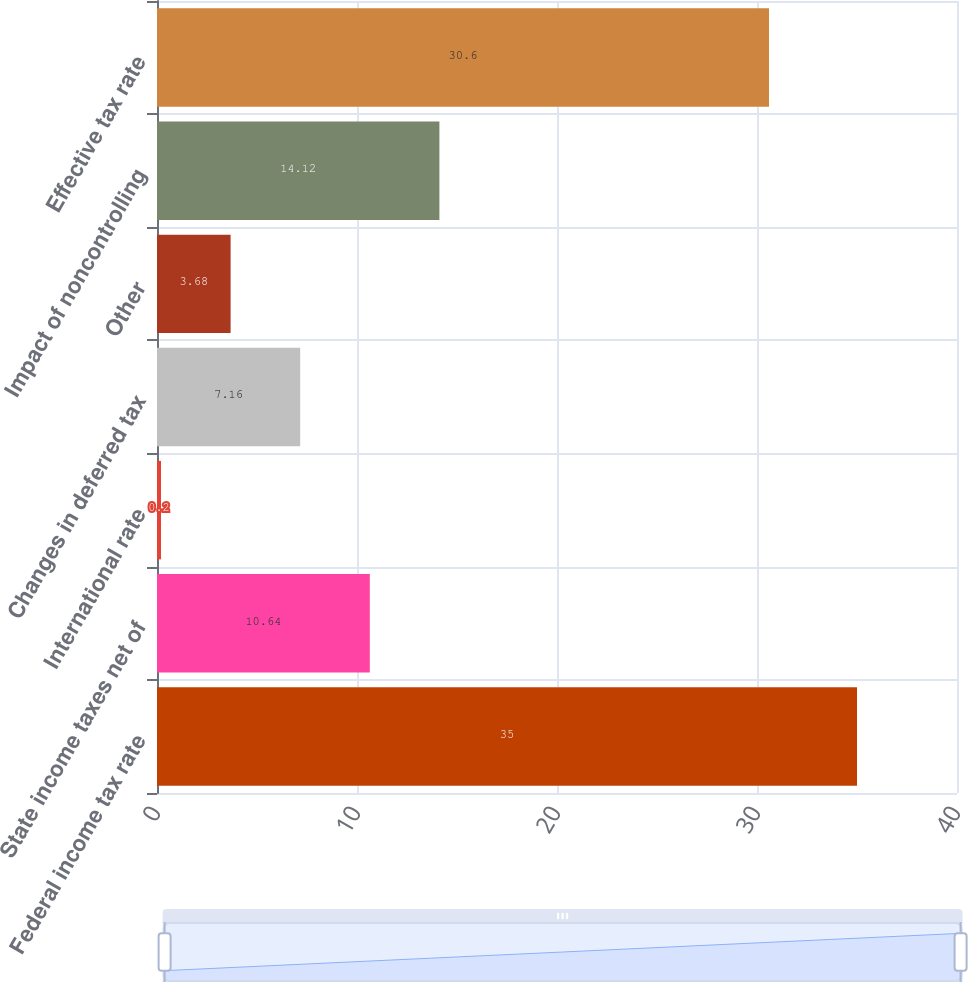Convert chart to OTSL. <chart><loc_0><loc_0><loc_500><loc_500><bar_chart><fcel>Federal income tax rate<fcel>State income taxes net of<fcel>International rate<fcel>Changes in deferred tax<fcel>Other<fcel>Impact of noncontrolling<fcel>Effective tax rate<nl><fcel>35<fcel>10.64<fcel>0.2<fcel>7.16<fcel>3.68<fcel>14.12<fcel>30.6<nl></chart> 